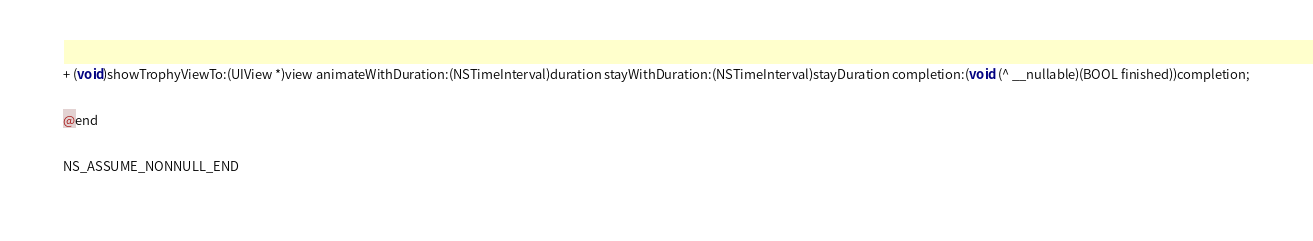<code> <loc_0><loc_0><loc_500><loc_500><_C_>+ (void)showTrophyViewTo:(UIView *)view animateWithDuration:(NSTimeInterval)duration stayWithDuration:(NSTimeInterval)stayDuration completion:(void (^ __nullable)(BOOL finished))completion;

@end

NS_ASSUME_NONNULL_END
</code> 